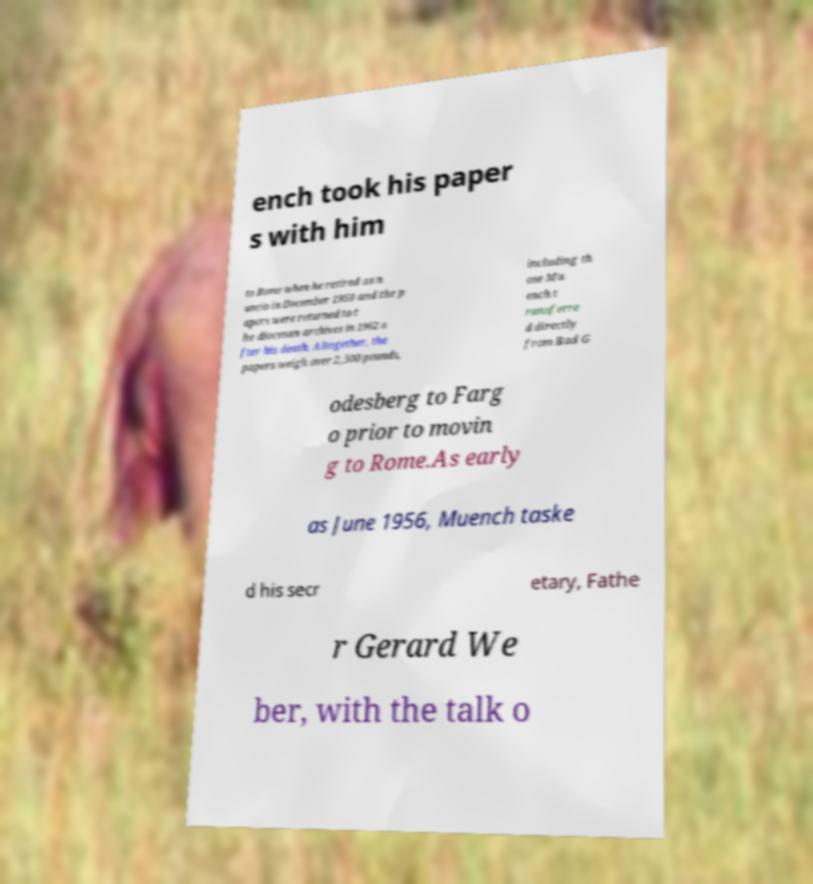There's text embedded in this image that I need extracted. Can you transcribe it verbatim? ench took his paper s with him to Rome when he retired as n uncio in December 1959 and the p apers were returned to t he diocesan archives in 1962 a fter his death. Altogether, the papers weigh over 2,500 pounds, including th ose Mu ench t ransferre d directly from Bad G odesberg to Farg o prior to movin g to Rome.As early as June 1956, Muench taske d his secr etary, Fathe r Gerard We ber, with the talk o 